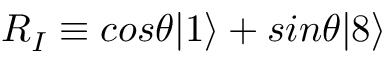<formula> <loc_0><loc_0><loc_500><loc_500>R _ { I } \equiv \cos \theta | 1 \rangle + \sin \theta | 8 \rangle</formula> 